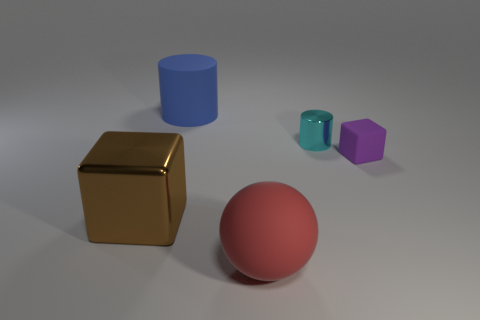Can you describe the lighting and shadows in the scene? The scene is lit from above, casting soft shadows directly underneath the objects. The lighting suggests an indoor setting with a diffused light source, providing subtle highlights on the tops of the objects and softening the edges of the shadows. 